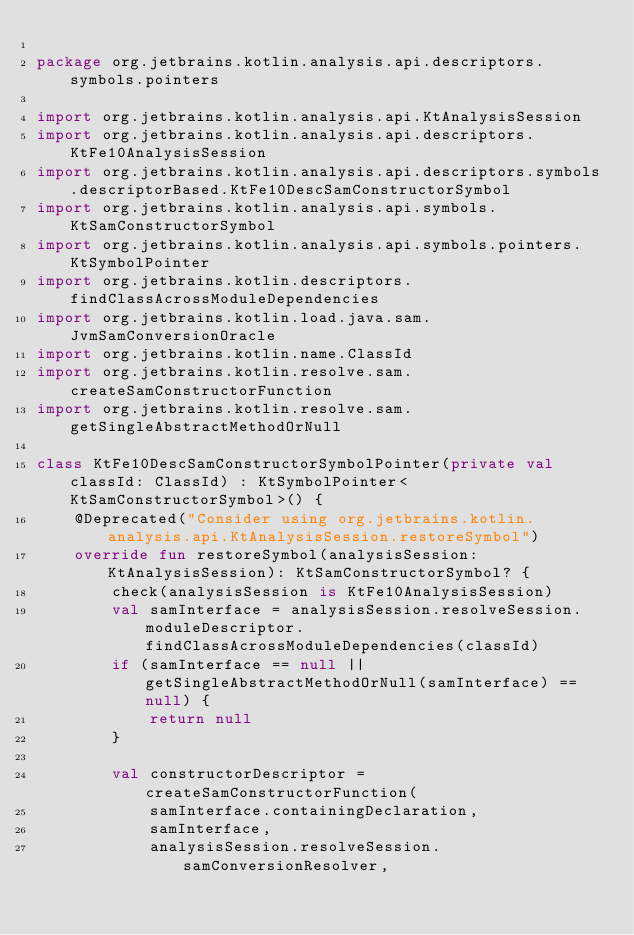<code> <loc_0><loc_0><loc_500><loc_500><_Kotlin_>
package org.jetbrains.kotlin.analysis.api.descriptors.symbols.pointers

import org.jetbrains.kotlin.analysis.api.KtAnalysisSession
import org.jetbrains.kotlin.analysis.api.descriptors.KtFe10AnalysisSession
import org.jetbrains.kotlin.analysis.api.descriptors.symbols.descriptorBased.KtFe10DescSamConstructorSymbol
import org.jetbrains.kotlin.analysis.api.symbols.KtSamConstructorSymbol
import org.jetbrains.kotlin.analysis.api.symbols.pointers.KtSymbolPointer
import org.jetbrains.kotlin.descriptors.findClassAcrossModuleDependencies
import org.jetbrains.kotlin.load.java.sam.JvmSamConversionOracle
import org.jetbrains.kotlin.name.ClassId
import org.jetbrains.kotlin.resolve.sam.createSamConstructorFunction
import org.jetbrains.kotlin.resolve.sam.getSingleAbstractMethodOrNull

class KtFe10DescSamConstructorSymbolPointer(private val classId: ClassId) : KtSymbolPointer<KtSamConstructorSymbol>() {
    @Deprecated("Consider using org.jetbrains.kotlin.analysis.api.KtAnalysisSession.restoreSymbol")
    override fun restoreSymbol(analysisSession: KtAnalysisSession): KtSamConstructorSymbol? {
        check(analysisSession is KtFe10AnalysisSession)
        val samInterface = analysisSession.resolveSession.moduleDescriptor.findClassAcrossModuleDependencies(classId)
        if (samInterface == null || getSingleAbstractMethodOrNull(samInterface) == null) {
            return null
        }

        val constructorDescriptor = createSamConstructorFunction(
            samInterface.containingDeclaration,
            samInterface,
            analysisSession.resolveSession.samConversionResolver,</code> 